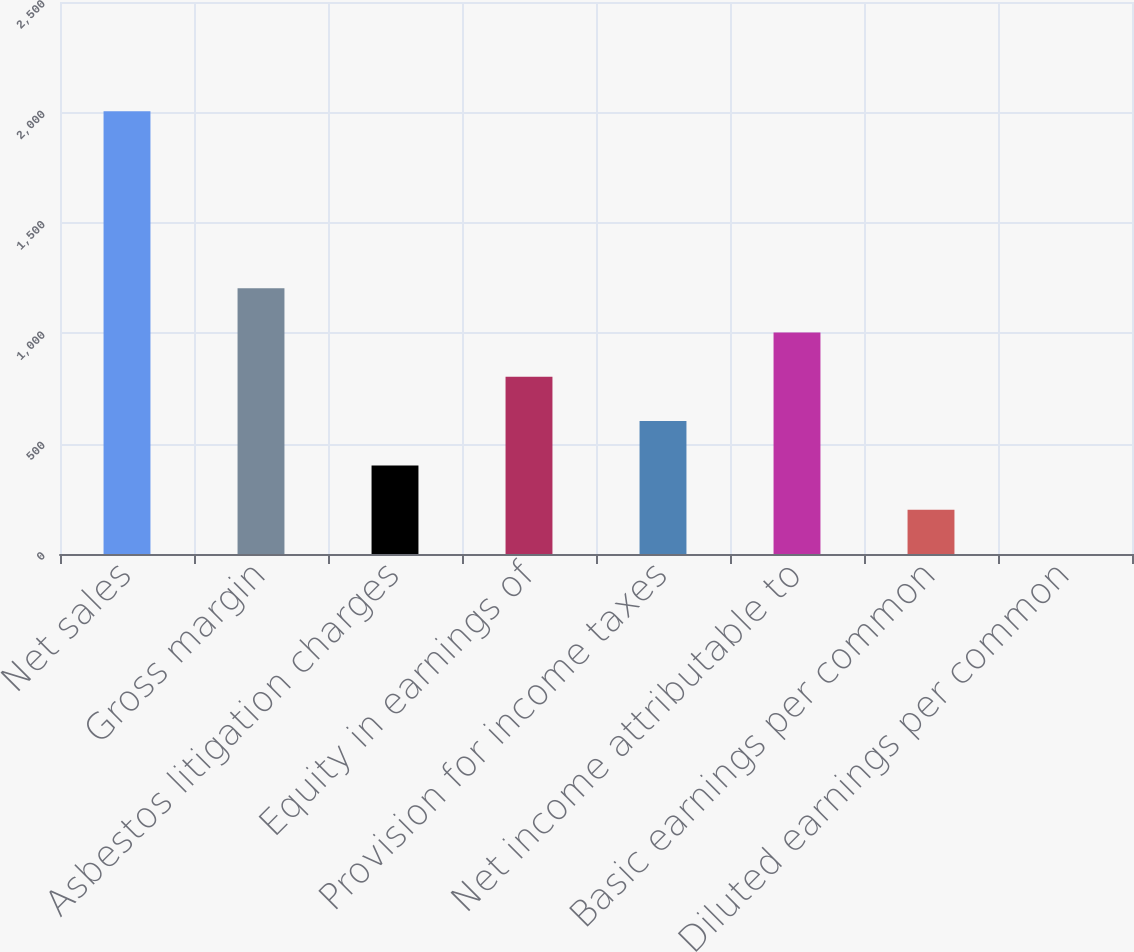Convert chart. <chart><loc_0><loc_0><loc_500><loc_500><bar_chart><fcel>Net sales<fcel>Gross margin<fcel>Asbestos litigation charges<fcel>Equity in earnings of<fcel>Provision for income taxes<fcel>Net income attributable to<fcel>Basic earnings per common<fcel>Diluted earnings per common<nl><fcel>2005<fcel>1203.17<fcel>401.37<fcel>802.27<fcel>601.82<fcel>1002.72<fcel>200.92<fcel>0.47<nl></chart> 